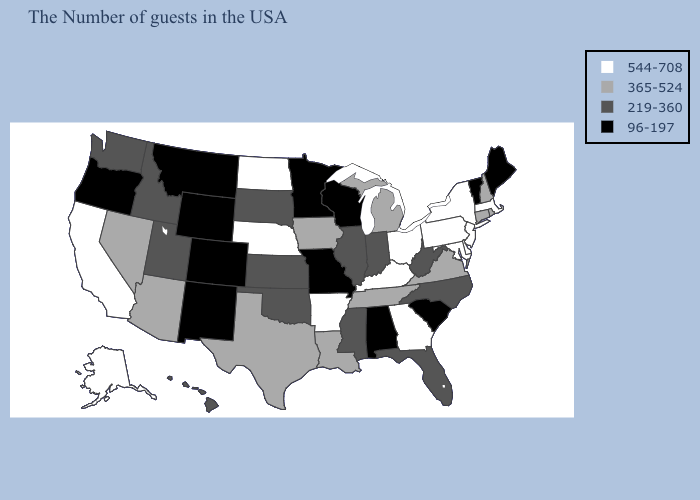What is the value of South Dakota?
Quick response, please. 219-360. What is the lowest value in the USA?
Short answer required. 96-197. Does New Hampshire have the highest value in the Northeast?
Concise answer only. No. Name the states that have a value in the range 219-360?
Quick response, please. North Carolina, West Virginia, Florida, Indiana, Illinois, Mississippi, Kansas, Oklahoma, South Dakota, Utah, Idaho, Washington, Hawaii. Among the states that border Florida , does Georgia have the highest value?
Be succinct. Yes. What is the value of Michigan?
Short answer required. 365-524. Name the states that have a value in the range 365-524?
Give a very brief answer. Rhode Island, New Hampshire, Connecticut, Virginia, Michigan, Tennessee, Louisiana, Iowa, Texas, Arizona, Nevada. Does the map have missing data?
Give a very brief answer. No. What is the value of New Jersey?
Concise answer only. 544-708. Among the states that border Iowa , does Missouri have the lowest value?
Be succinct. Yes. Name the states that have a value in the range 96-197?
Answer briefly. Maine, Vermont, South Carolina, Alabama, Wisconsin, Missouri, Minnesota, Wyoming, Colorado, New Mexico, Montana, Oregon. Among the states that border Washington , does Idaho have the lowest value?
Be succinct. No. Does the map have missing data?
Short answer required. No. Name the states that have a value in the range 544-708?
Write a very short answer. Massachusetts, New York, New Jersey, Delaware, Maryland, Pennsylvania, Ohio, Georgia, Kentucky, Arkansas, Nebraska, North Dakota, California, Alaska. Which states have the lowest value in the USA?
Write a very short answer. Maine, Vermont, South Carolina, Alabama, Wisconsin, Missouri, Minnesota, Wyoming, Colorado, New Mexico, Montana, Oregon. 